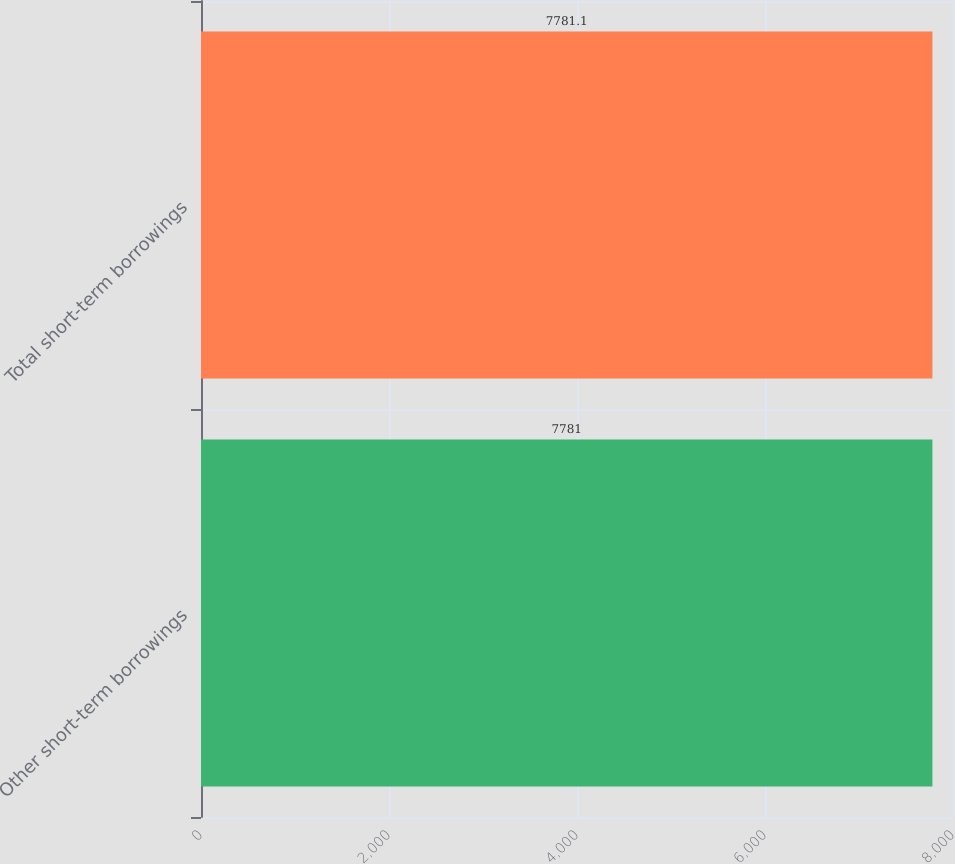Convert chart to OTSL. <chart><loc_0><loc_0><loc_500><loc_500><bar_chart><fcel>Other short-term borrowings<fcel>Total short-term borrowings<nl><fcel>7781<fcel>7781.1<nl></chart> 